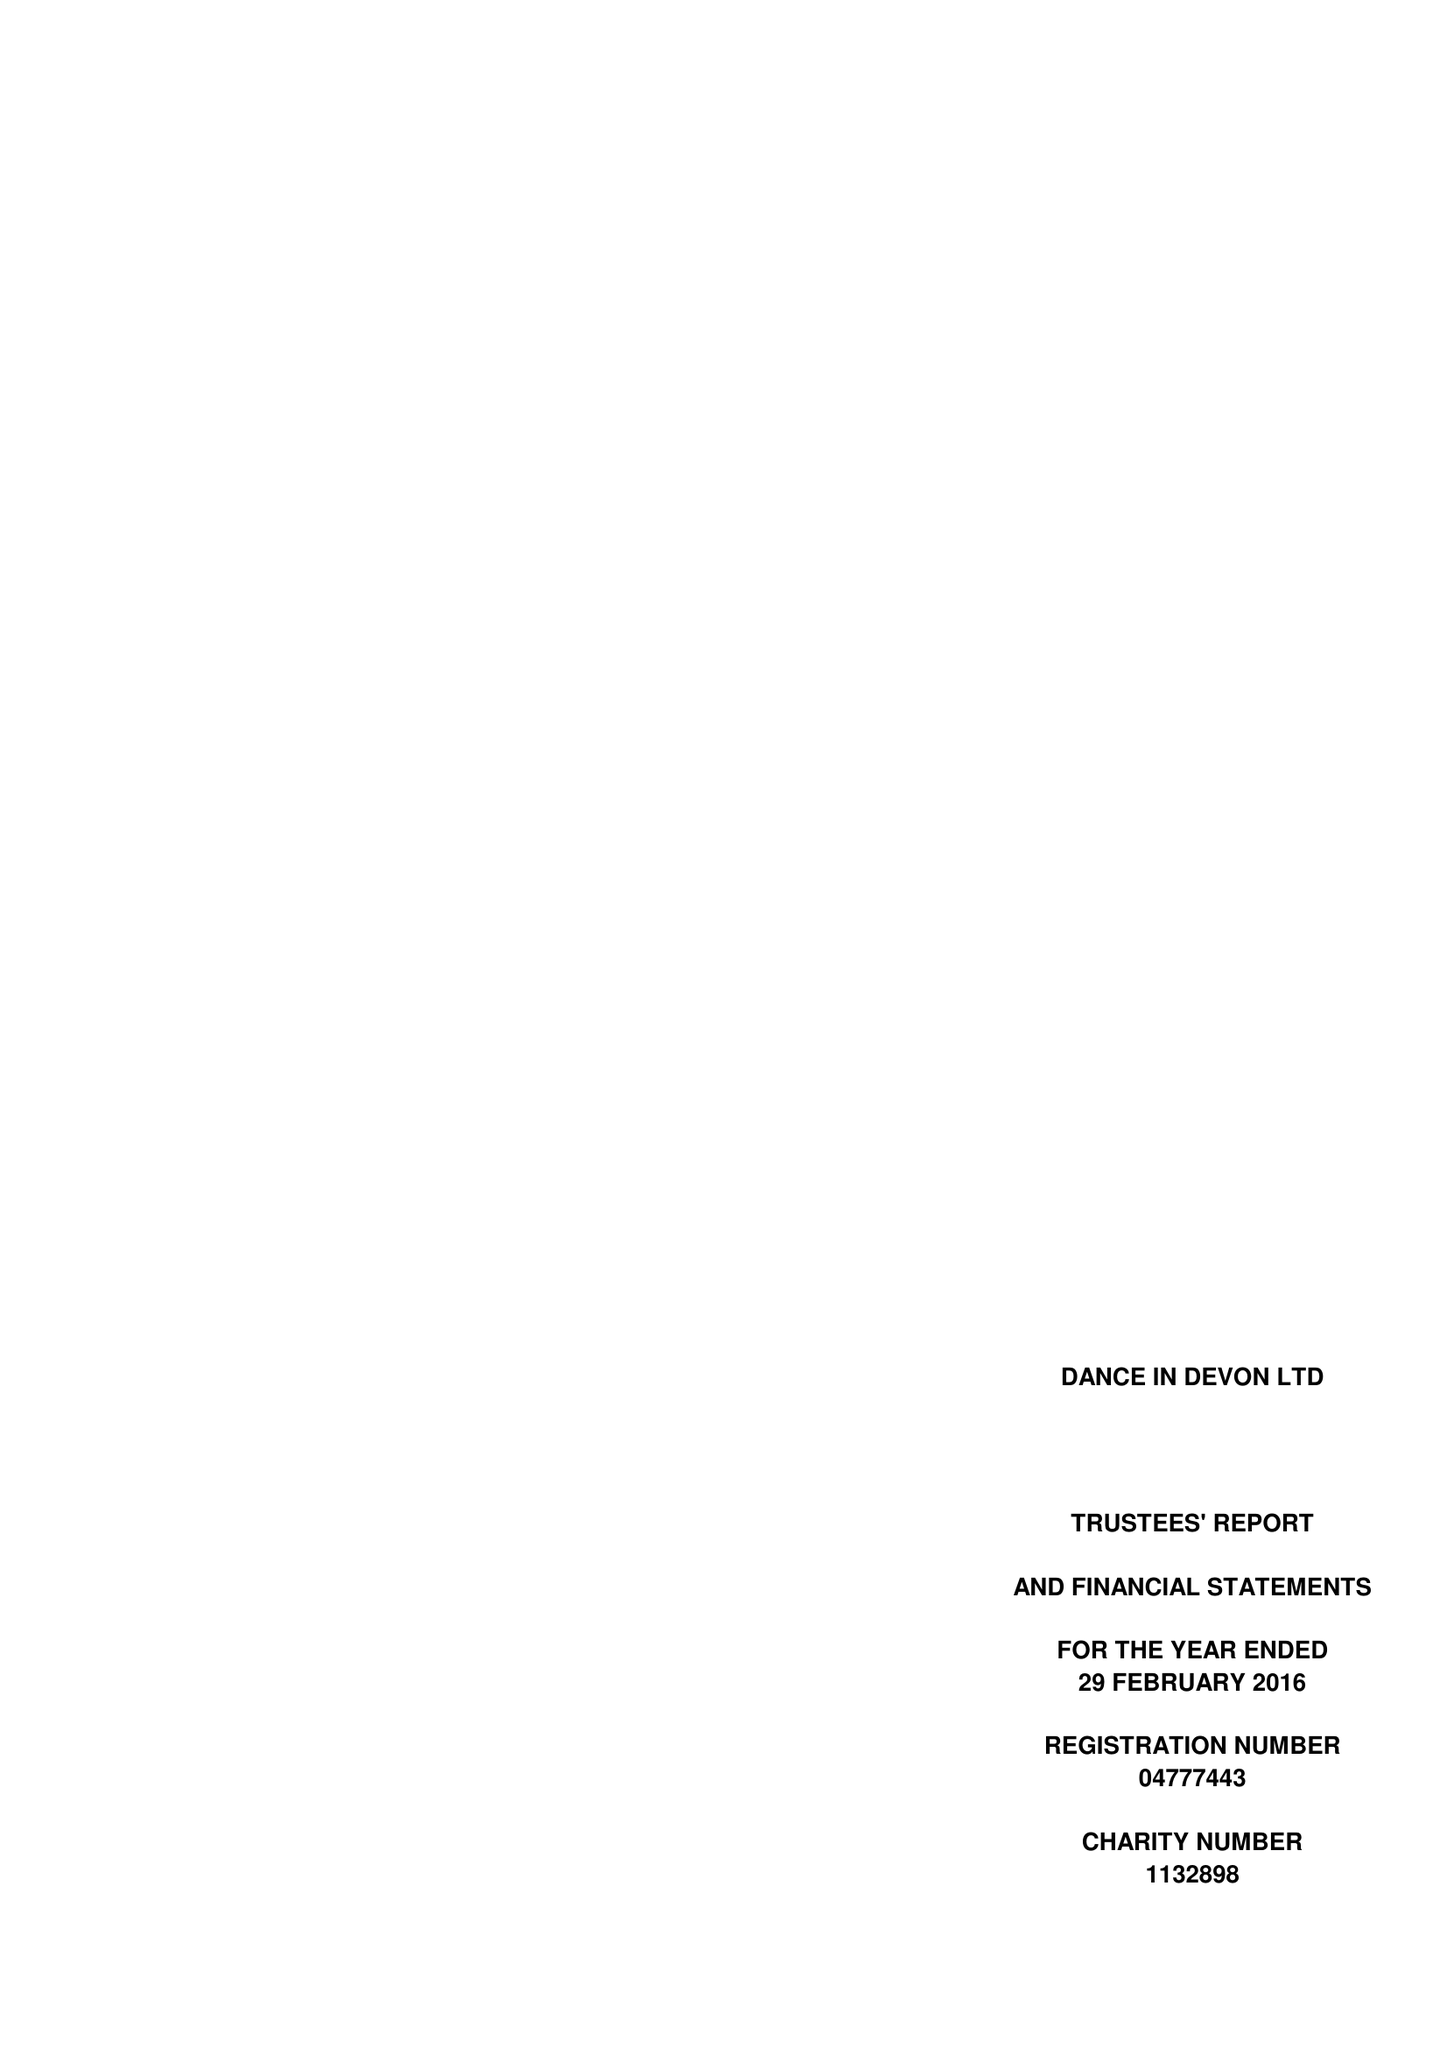What is the value for the charity_name?
Answer the question using a single word or phrase. Dance In Devon Ltd. 